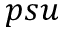Convert formula to latex. <formula><loc_0><loc_0><loc_500><loc_500>p s u</formula> 